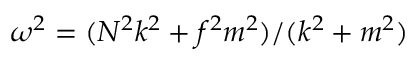Convert formula to latex. <formula><loc_0><loc_0><loc_500><loc_500>\omega ^ { 2 } = ( N ^ { 2 } k ^ { 2 } + f ^ { 2 } m ^ { 2 } ) / ( k ^ { 2 } + m ^ { 2 } )</formula> 